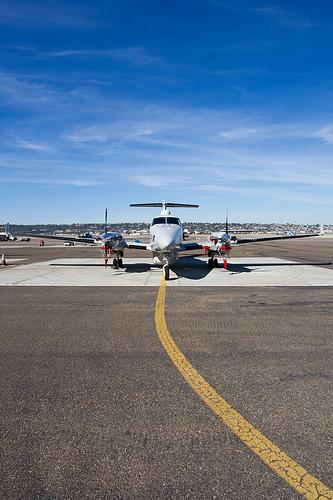Question: where was the picture taken?
Choices:
A. Hotel room.
B. Art museum.
C. Cruise ship.
D. At the airport.
Answer with the letter. Answer: D Question: what color is the plane?
Choices:
A. Grey.
B. Blue.
C. Yellow.
D. White.
Answer with the letter. Answer: D Question: what is in the sky?
Choices:
A. Bird.
B. Clouds.
C. Plane.
D. Sun.
Answer with the letter. Answer: B Question: how many planes are there?
Choices:
A. One.
B. Two.
C. Three.
D. None.
Answer with the letter. Answer: A 